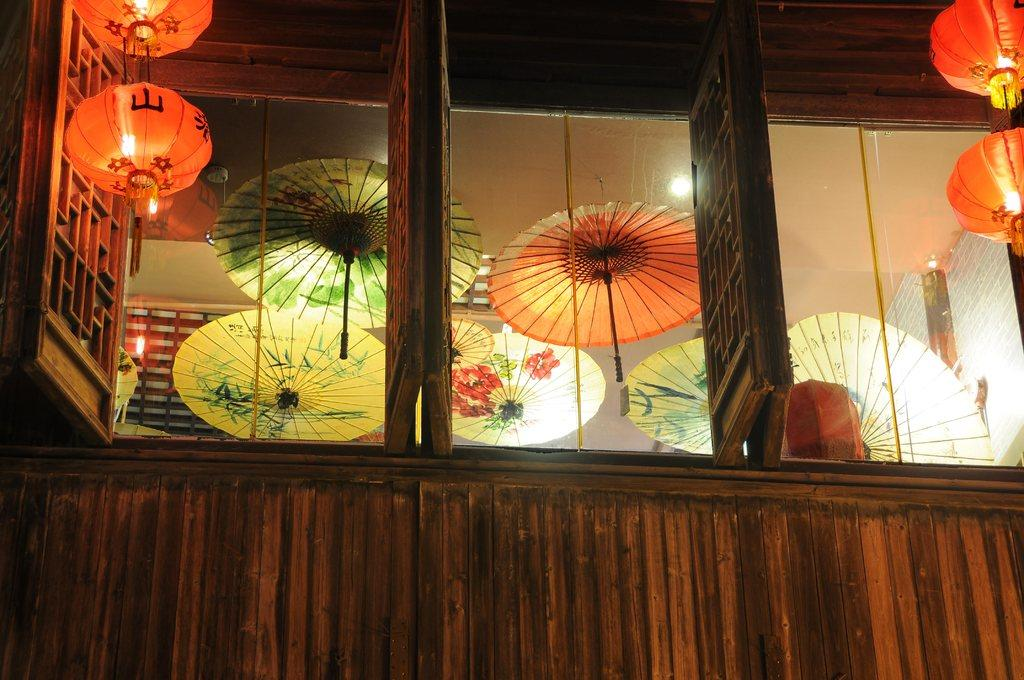What can be seen hanging from the top in the image? There are umbrellas hanging from the top in the image. What else is present on the top in the image? There are lights on the top in the image. Can you describe a feature of the building in the image? There is a window on the building in the image. Where is the faucet located in the image? There is no faucet present in the image. What is the value of the umbrellas in the image? The value of the umbrellas cannot be determined from the image alone. 